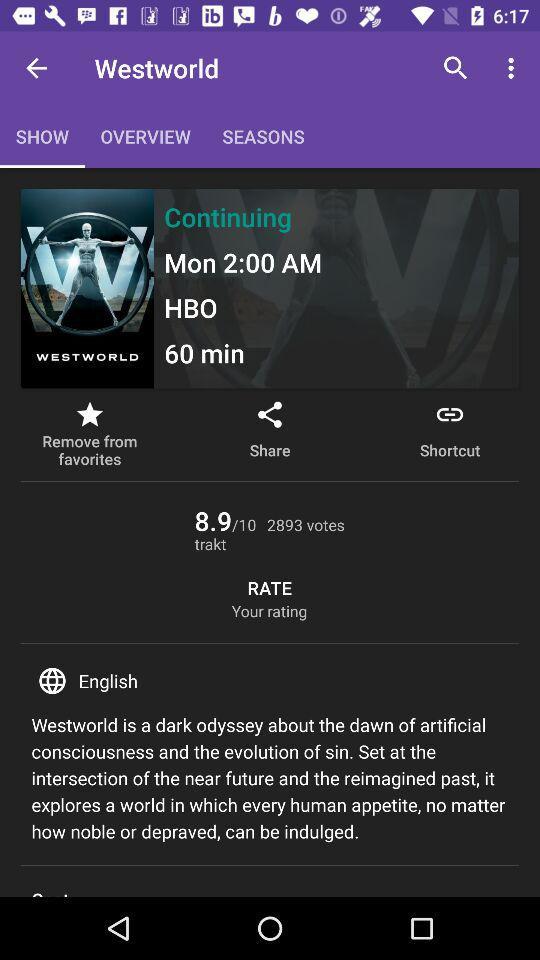What is the time of the show? The time of the show is 2:00 AM. 